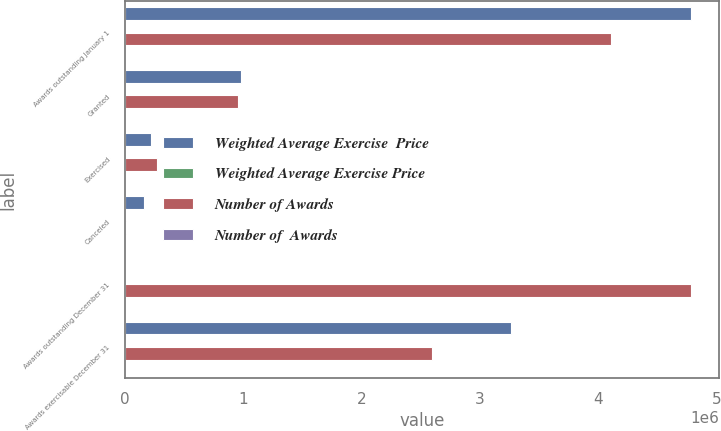Convert chart. <chart><loc_0><loc_0><loc_500><loc_500><stacked_bar_chart><ecel><fcel>Awards outstanding January 1<fcel>Granted<fcel>Exercised<fcel>Canceled<fcel>Awards outstanding December 31<fcel>Awards exercisable December 31<nl><fcel>Weighted Average Exercise  Price<fcel>4.78704e+06<fcel>980000<fcel>226695<fcel>164946<fcel>46.4<fcel>3.26298e+06<nl><fcel>Weighted Average Exercise Price<fcel>28.09<fcel>43.63<fcel>19.96<fcel>41.96<fcel>30.84<fcel>24.1<nl><fcel>Number of Awards<fcel>4.11044e+06<fcel>959250<fcel>270641<fcel>12010<fcel>4.78704e+06<fcel>2.60003e+06<nl><fcel>Number of  Awards<fcel>23.12<fcel>46.4<fcel>17.56<fcel>30.13<fcel>28.09<fcel>20.84<nl></chart> 